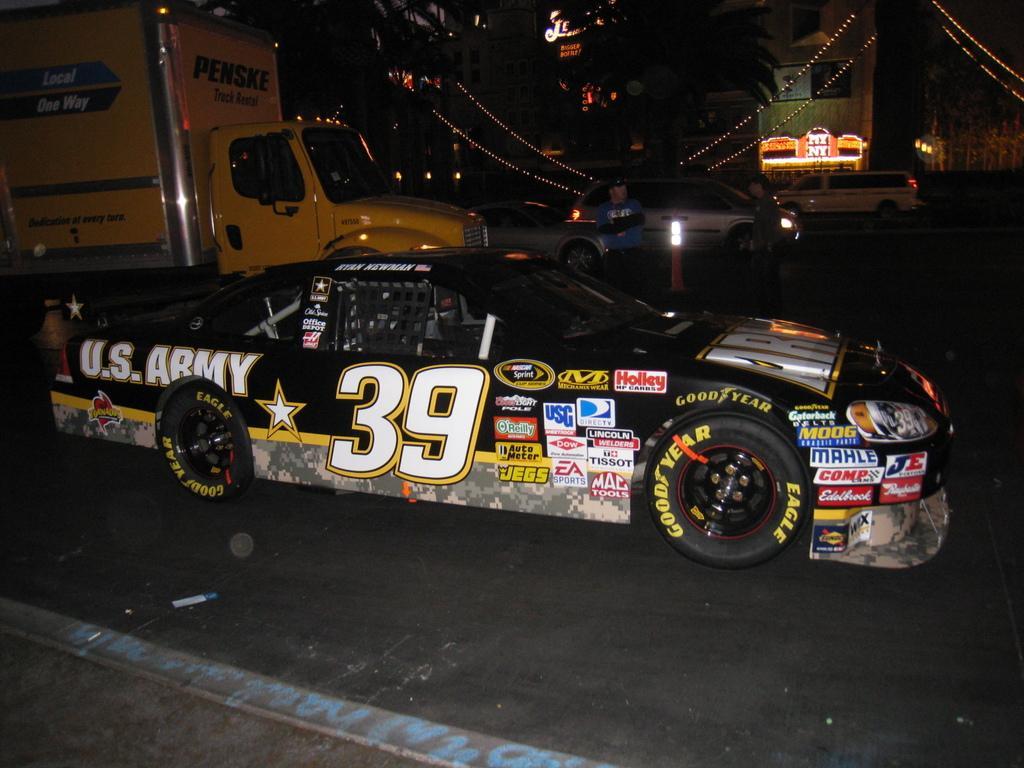How would you summarize this image in a sentence or two? In this image there are a few cars and trucks on the road, on the other side of the road there are trees and buildings. 